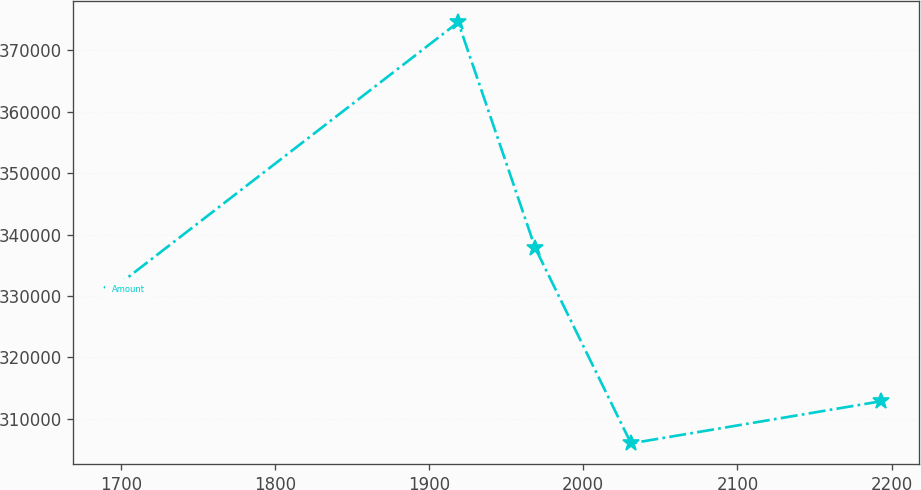<chart> <loc_0><loc_0><loc_500><loc_500><line_chart><ecel><fcel>Amount<nl><fcel>1694.05<fcel>330992<nl><fcel>1918.86<fcel>374577<nl><fcel>1968.77<fcel>337849<nl><fcel>2030.97<fcel>306008<nl><fcel>2193.13<fcel>312865<nl></chart> 